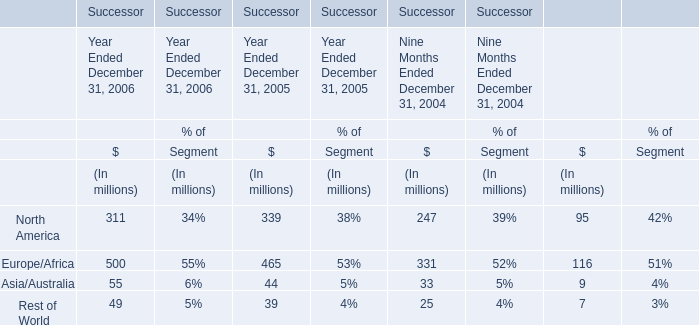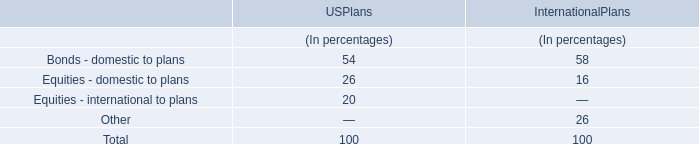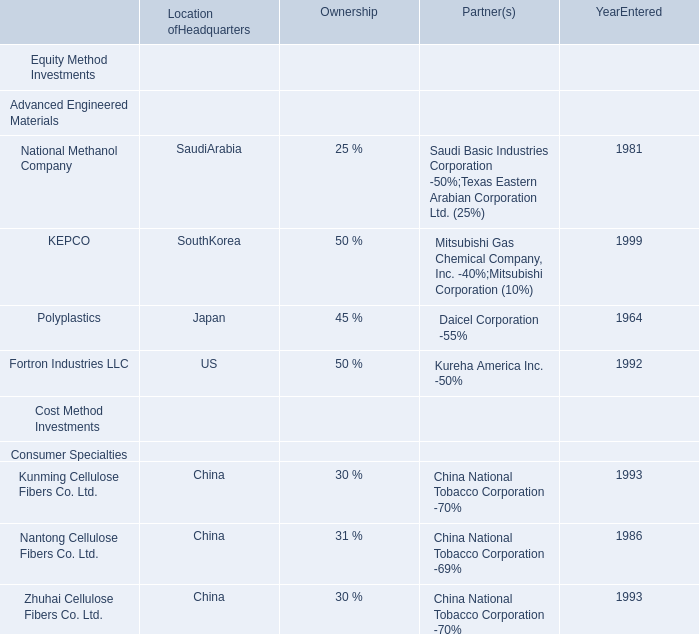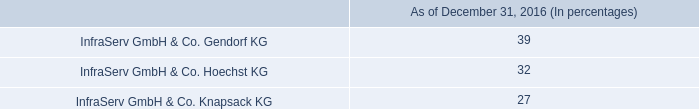what is the total research and development for the year 2014 through 2016 in millions 
Computations: ((78 + 119) + 86)
Answer: 283.0. 